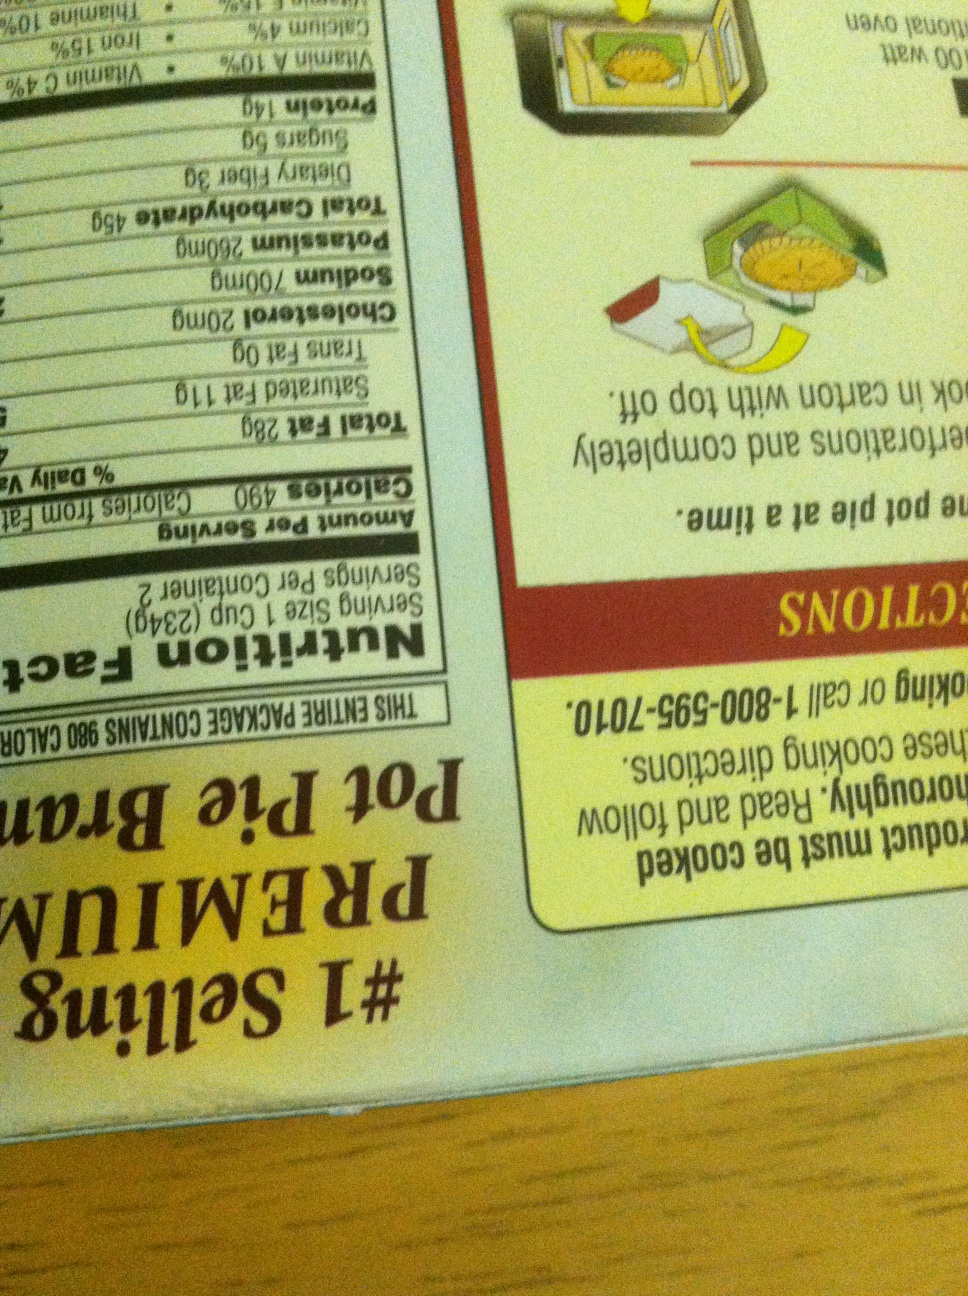What are the calories per serving for the pot pie shown on the box? The pot pie contains 490 calories per serving. It's important to consider this in the context of your daily caloric intake. Can you also tell me the total fat content per serving? Sure! The total fat content per serving of the pot pie is 29 grams. This includes 14 grams of saturated fat and 0.5 grams of trans fat. Are there any dietary fibers in this pot pie? Yes, the pot pie contains 4 grams of dietary fiber per serving. Is this pot pie microwavable? Absolutely! The pot pie can be cooked in a microwave oven as indicated in the instructions on the box. Simply remove it from the carton, follow the preparation steps, and it will be ready in just a few minutes. 